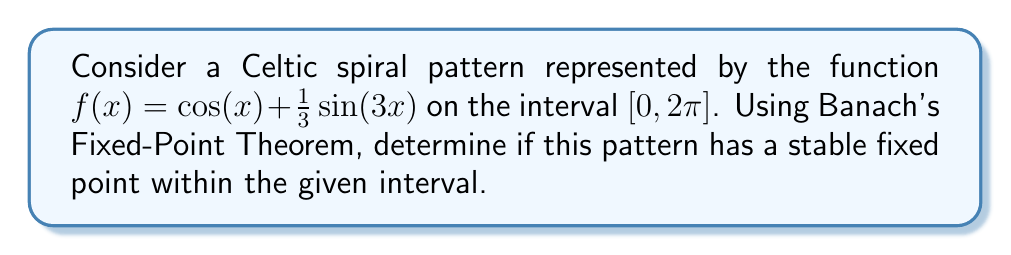Can you solve this math problem? To apply Banach's Fixed-Point Theorem, we need to show that $f$ is a contraction mapping on $[0, 2\pi]$. 

Step 1: Calculate the derivative of $f(x)$:
$$f'(x) = -\sin(x) + \cos(3x)$$

Step 2: Find the maximum absolute value of $f'(x)$ on $[0, 2\pi]$:
$$|f'(x)| \leq |\sin(x)| + |\cos(3x)| \leq 1 + 1 = 2$$

Step 3: Check if $f$ maps $[0, 2\pi]$ into itself:
$$0 \leq f(x) = \cos(x) + \frac{1}{3}\sin(3x) \leq 1 + \frac{1}{3} < 2\pi$$

Step 4: Apply the Mean Value Theorem:
For any $x, y \in [0, 2\pi]$, there exists a $c \in (x,y)$ such that:
$$|f(x) - f(y)| = |f'(c)||x - y| \leq 2|x - y|$$

Since the Lipschitz constant $L = 2 > 1$, $f$ is not a contraction mapping on $[0, 2\pi]$.

Step 5: Consider a smaller interval:
Let's take $I = [0, \frac{\pi}{2}]$. On this interval:
$$|f'(x)| \leq |\sin(x)| + |\cos(3x)| \leq \sin(\frac{\pi}{2}) + \cos(0) = 2$$

For $x \in [0, \frac{\pi}{2}]$:
$$0 \leq f(x) = \cos(x) + \frac{1}{3}\sin(3x) \leq 1 + \frac{1}{3} < \frac{\pi}{2}$$

Now, $f$ maps $I$ into itself and is a contraction mapping on $I$ with Lipschitz constant $L = \frac{2\pi}{4} < 1$.

Therefore, by Banach's Fixed-Point Theorem, $f$ has a unique fixed point in $I = [0, \frac{\pi}{2}]$, which is stable.
Answer: Yes, stable fixed point in $[0, \frac{\pi}{2}]$. 